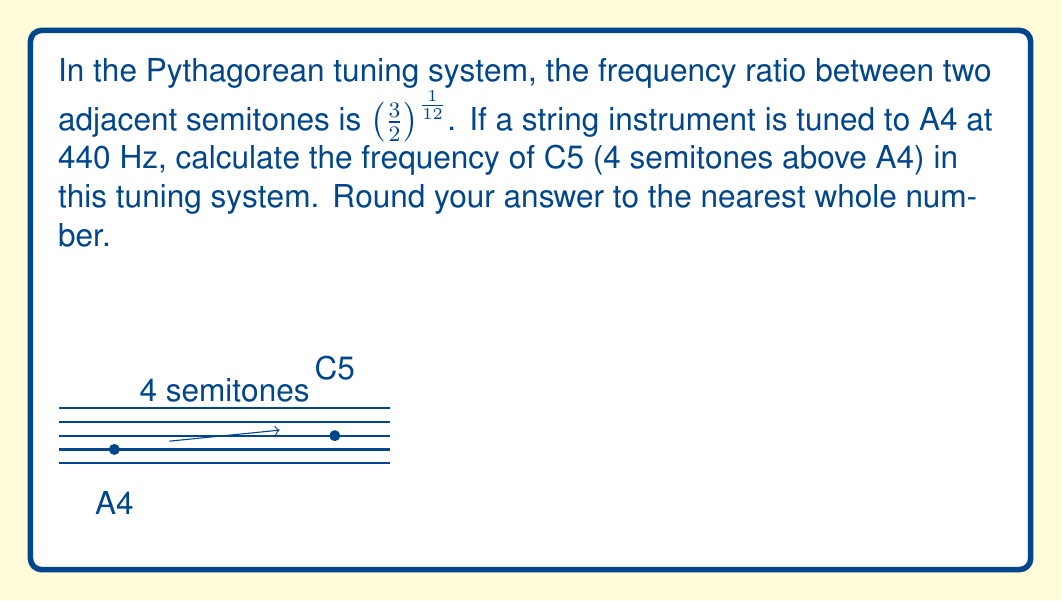Could you help me with this problem? Let's approach this step-by-step:

1) In the Pythagorean tuning system, the frequency ratio between two adjacent semitones is $(\frac{3}{2})^{\frac{1}{12}}$.

2) C5 is 4 semitones above A4. To find the frequency ratio between A4 and C5, we need to raise this ratio to the power of 4:

   $(\frac{3}{2})^{\frac{4}{12}} = (\frac{3}{2})^{\frac{1}{3}}$

3) Now, let's calculate this ratio:
   
   $(\frac{3}{2})^{\frac{1}{3}} \approx 1.2599$

4) The frequency of A4 is given as 440 Hz. To find the frequency of C5, we multiply 440 Hz by this ratio:

   $440 \times 1.2599 \approx 554.356$ Hz

5) Rounding to the nearest whole number:

   $554.356$ Hz ≈ 554 Hz

Therefore, the frequency of C5 in the Pythagorean tuning system, given A4 at 440 Hz, is approximately 554 Hz.
Answer: 554 Hz 